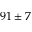<formula> <loc_0><loc_0><loc_500><loc_500>9 1 \pm 7</formula> 